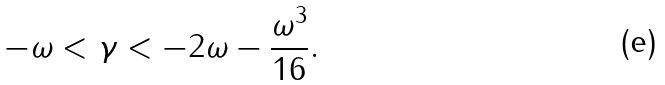Convert formula to latex. <formula><loc_0><loc_0><loc_500><loc_500>- \omega < \gamma < - 2 \omega - \frac { \omega ^ { 3 } } { 1 6 } .</formula> 